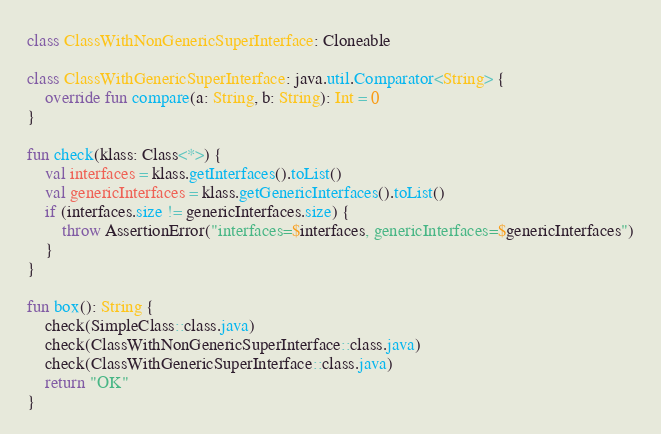<code> <loc_0><loc_0><loc_500><loc_500><_Kotlin_>
class ClassWithNonGenericSuperInterface: Cloneable

class ClassWithGenericSuperInterface: java.util.Comparator<String> {
    override fun compare(a: String, b: String): Int = 0
}

fun check(klass: Class<*>) {
    val interfaces = klass.getInterfaces().toList()
    val genericInterfaces = klass.getGenericInterfaces().toList()
    if (interfaces.size != genericInterfaces.size) {
        throw AssertionError("interfaces=$interfaces, genericInterfaces=$genericInterfaces")
    }
}

fun box(): String {
    check(SimpleClass::class.java)
    check(ClassWithNonGenericSuperInterface::class.java)
    check(ClassWithGenericSuperInterface::class.java)
    return "OK"
}
</code> 